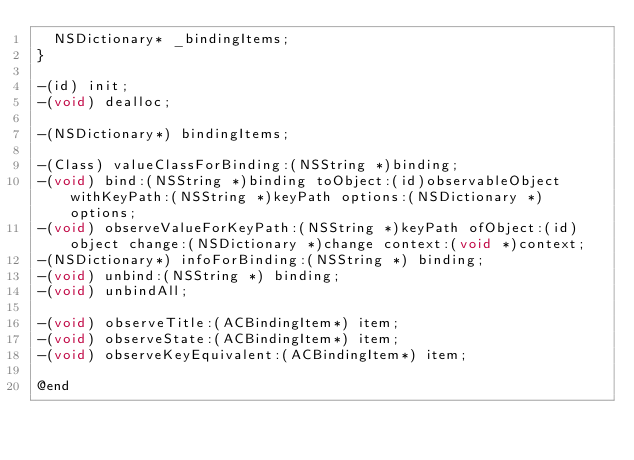<code> <loc_0><loc_0><loc_500><loc_500><_C_>	NSDictionary* _bindingItems;
}

-(id) init;
-(void) dealloc;

-(NSDictionary*) bindingItems;

-(Class) valueClassForBinding:(NSString *)binding;
-(void) bind:(NSString *)binding toObject:(id)observableObject withKeyPath:(NSString *)keyPath options:(NSDictionary *) options;
-(void) observeValueForKeyPath:(NSString *)keyPath ofObject:(id)object change:(NSDictionary *)change context:(void *)context;
-(NSDictionary*) infoForBinding:(NSString *) binding;
-(void) unbind:(NSString *) binding;
-(void) unbindAll;

-(void) observeTitle:(ACBindingItem*) item;
-(void) observeState:(ACBindingItem*) item;
-(void) observeKeyEquivalent:(ACBindingItem*) item;

@end
</code> 